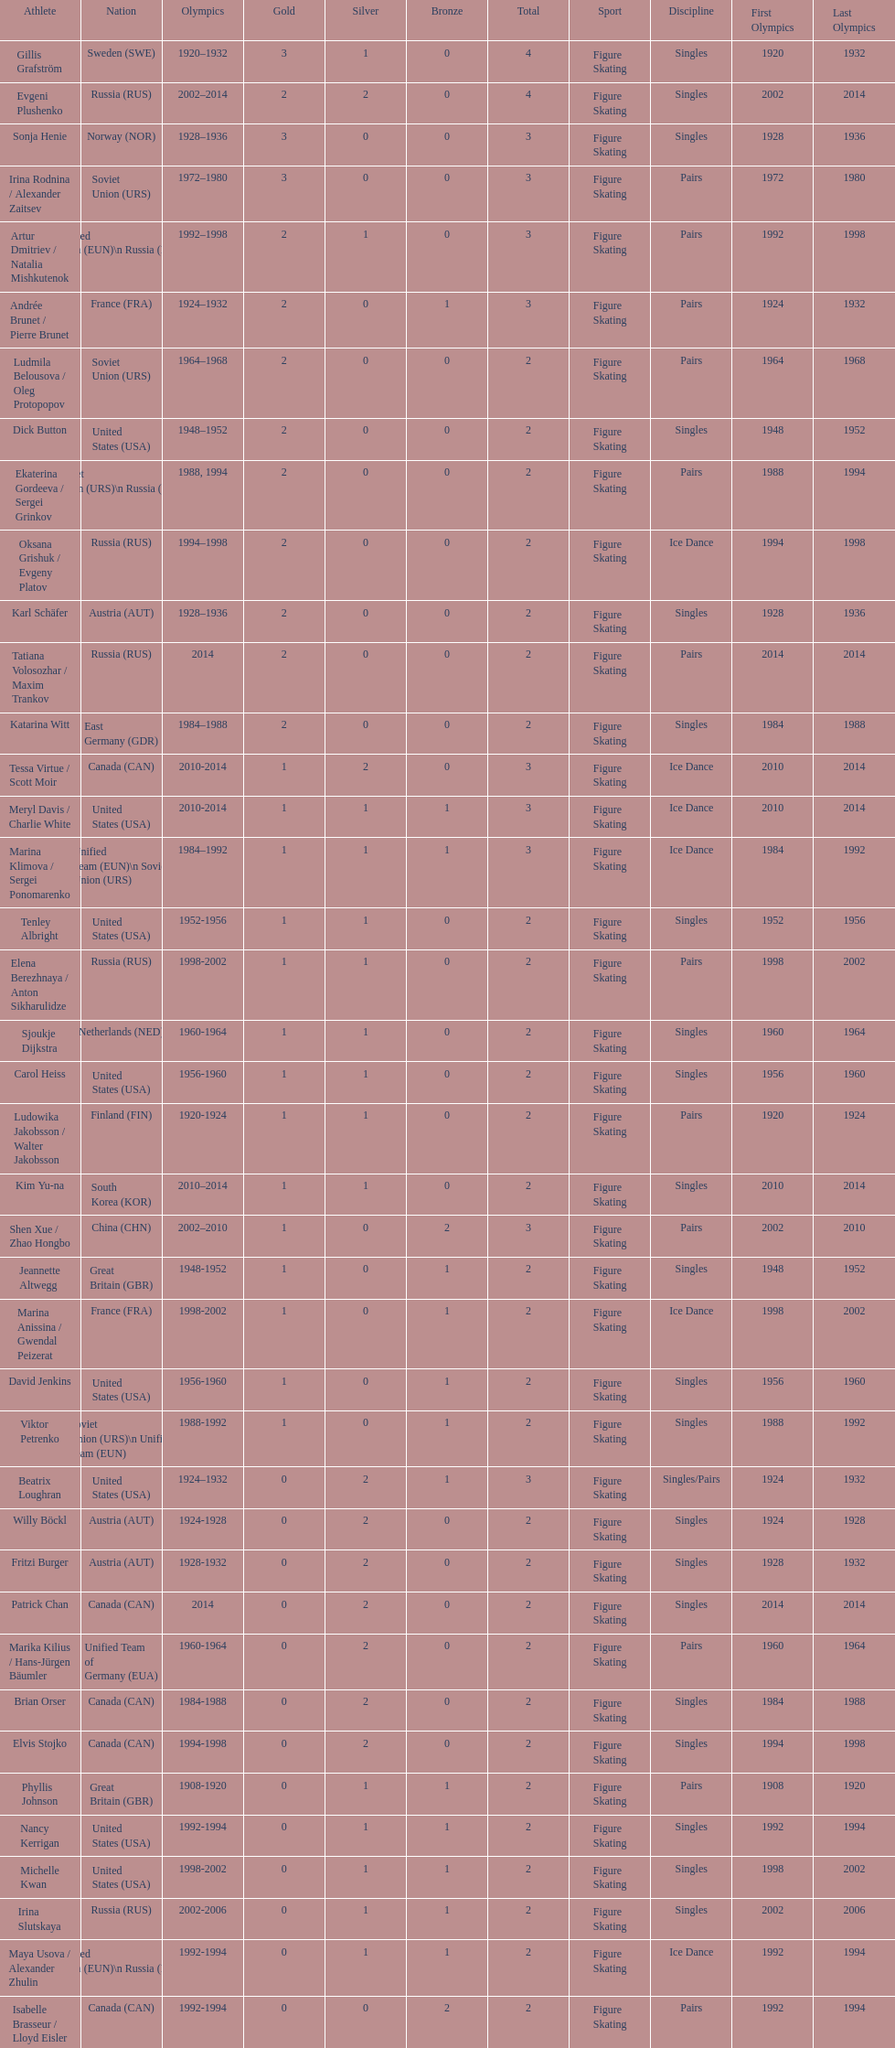Which nation was the first to win three gold medals for olympic figure skating? Sweden. 